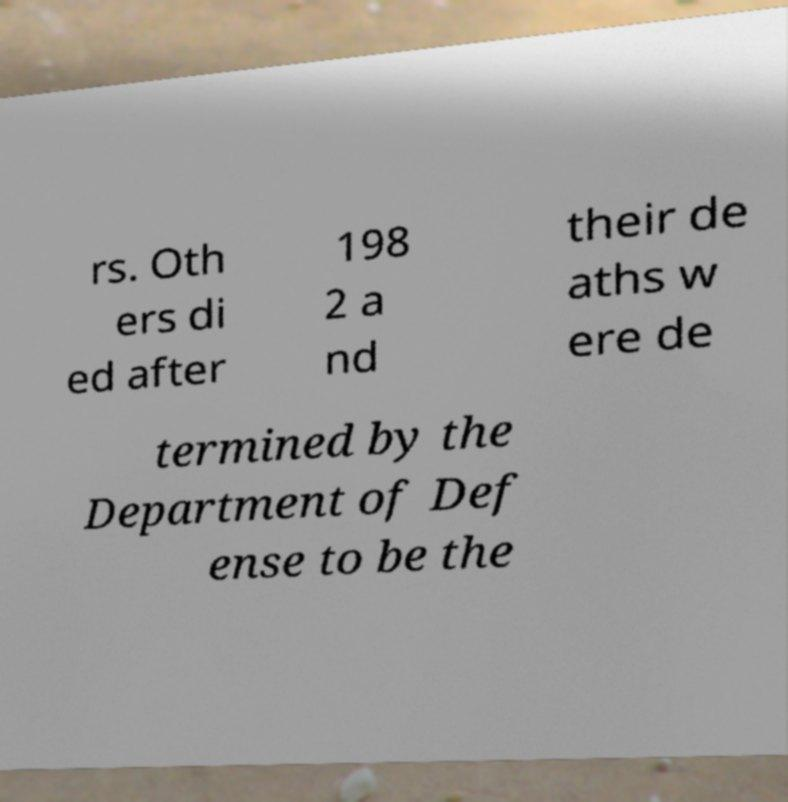Can you read and provide the text displayed in the image?This photo seems to have some interesting text. Can you extract and type it out for me? rs. Oth ers di ed after 198 2 a nd their de aths w ere de termined by the Department of Def ense to be the 